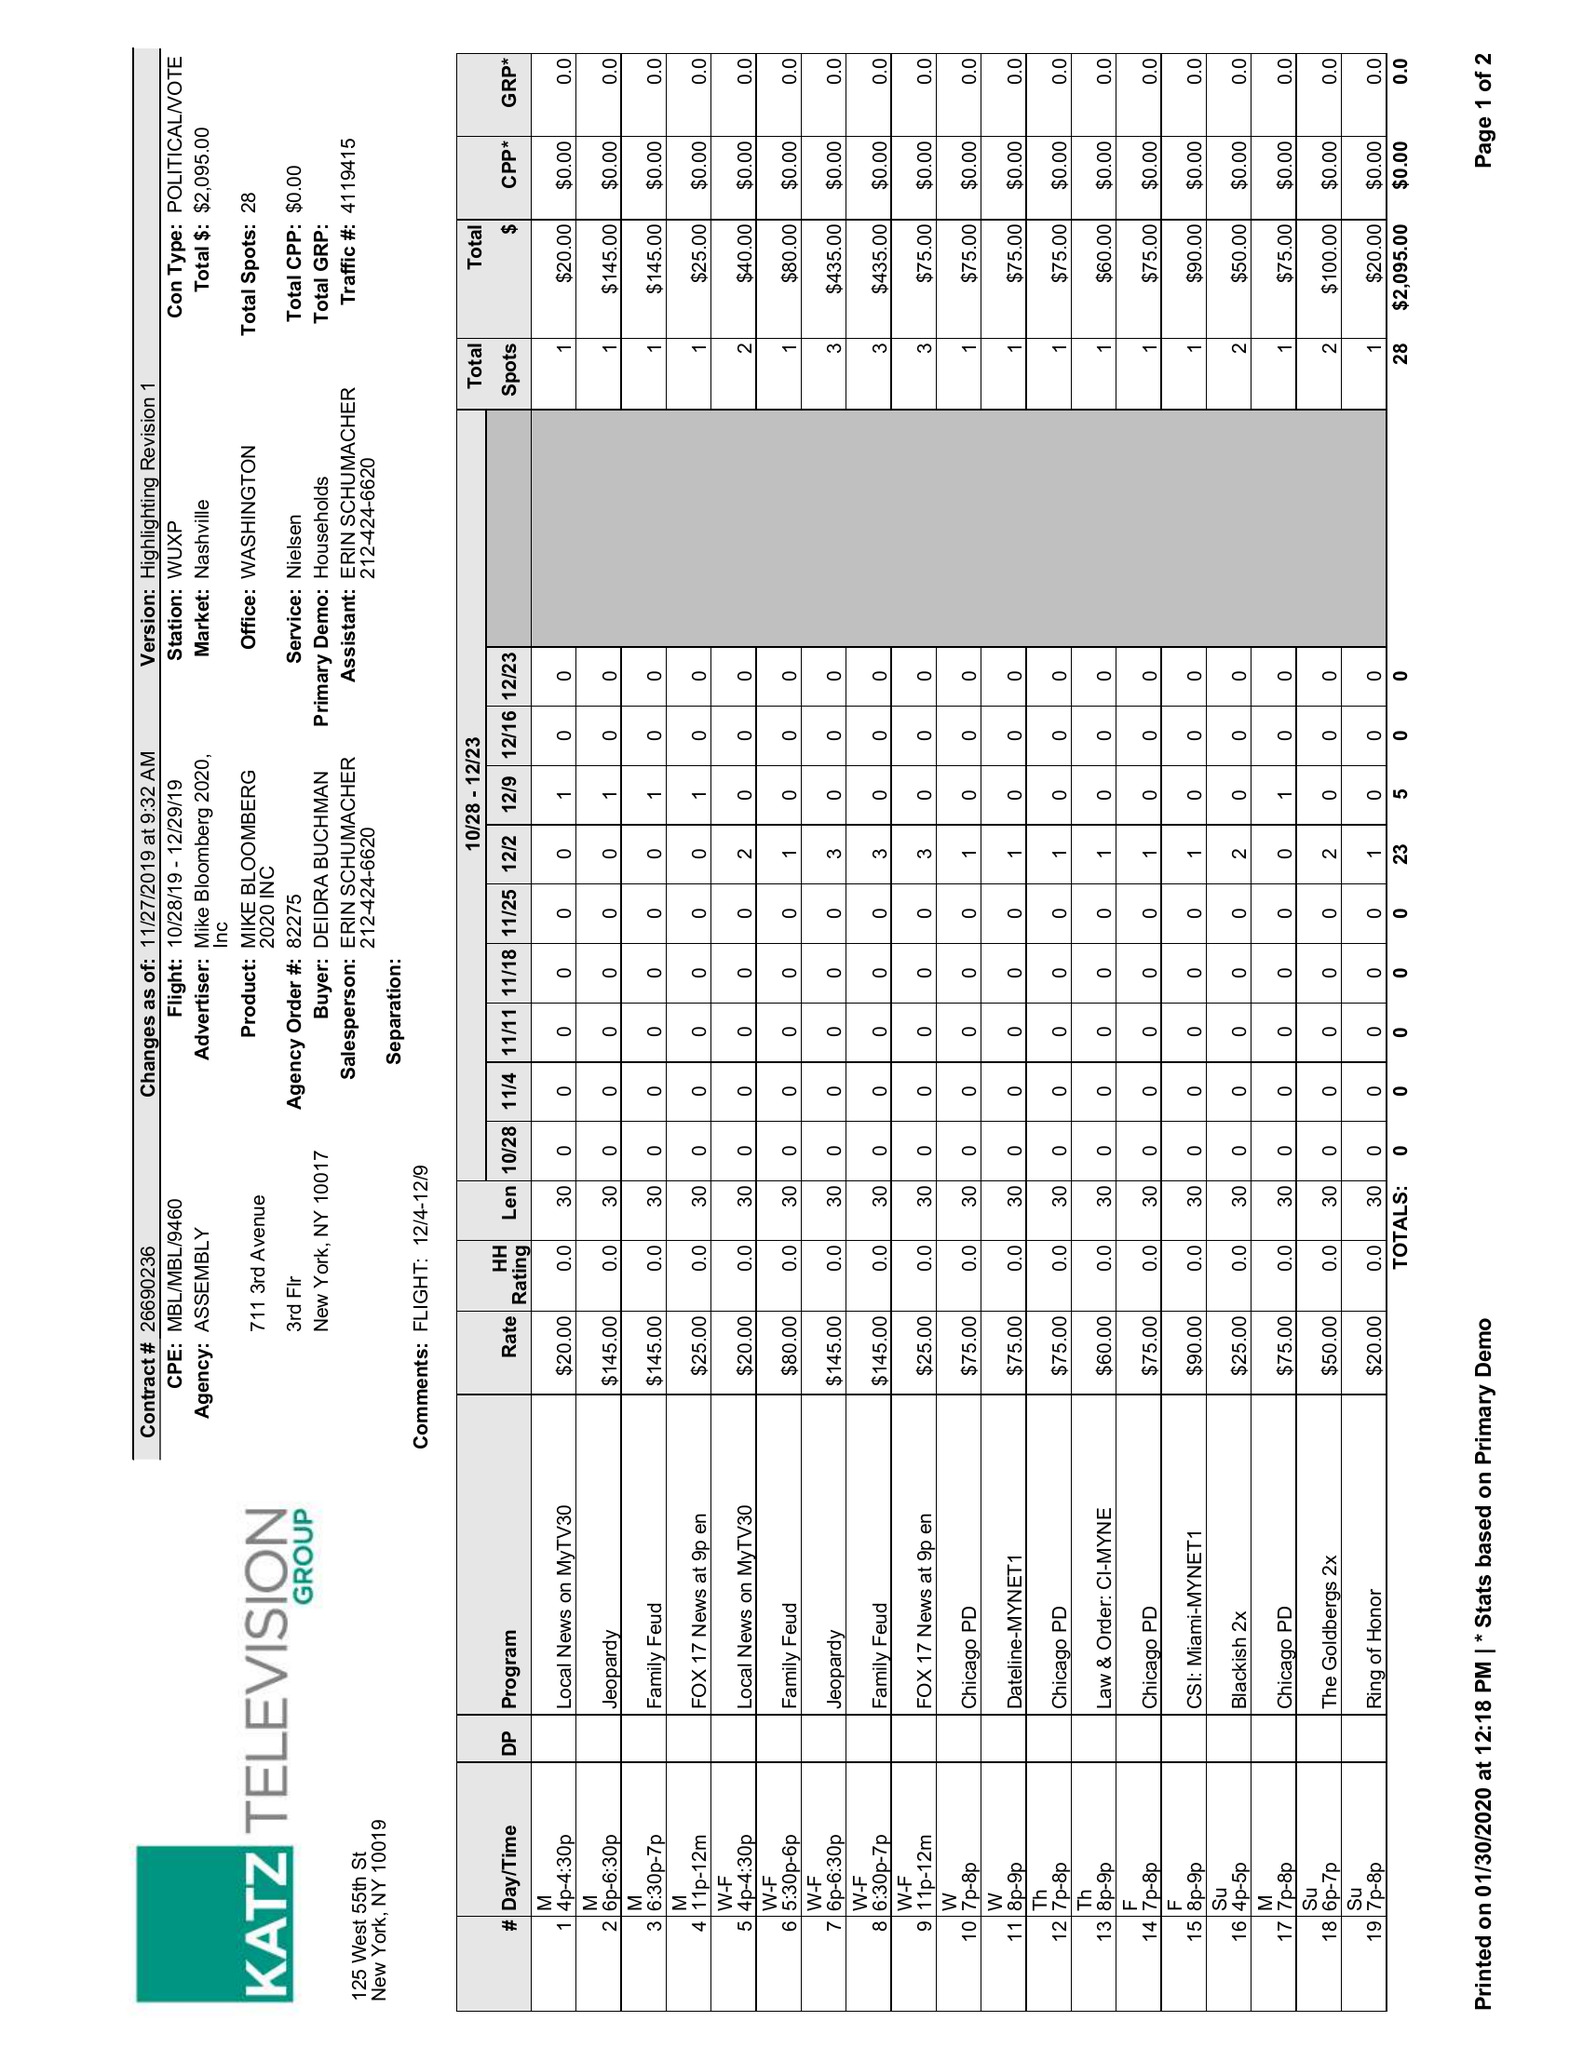What is the value for the gross_amount?
Answer the question using a single word or phrase. 2095.00 